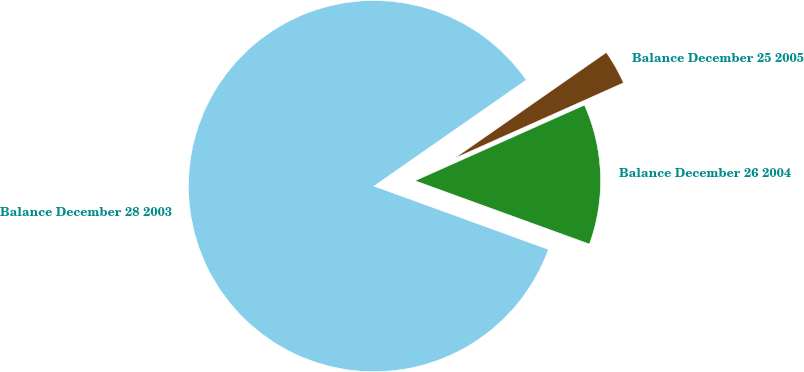<chart> <loc_0><loc_0><loc_500><loc_500><pie_chart><fcel>Balance December 28 2003<fcel>Balance December 26 2004<fcel>Balance December 25 2005<nl><fcel>84.77%<fcel>12.23%<fcel>3.0%<nl></chart> 